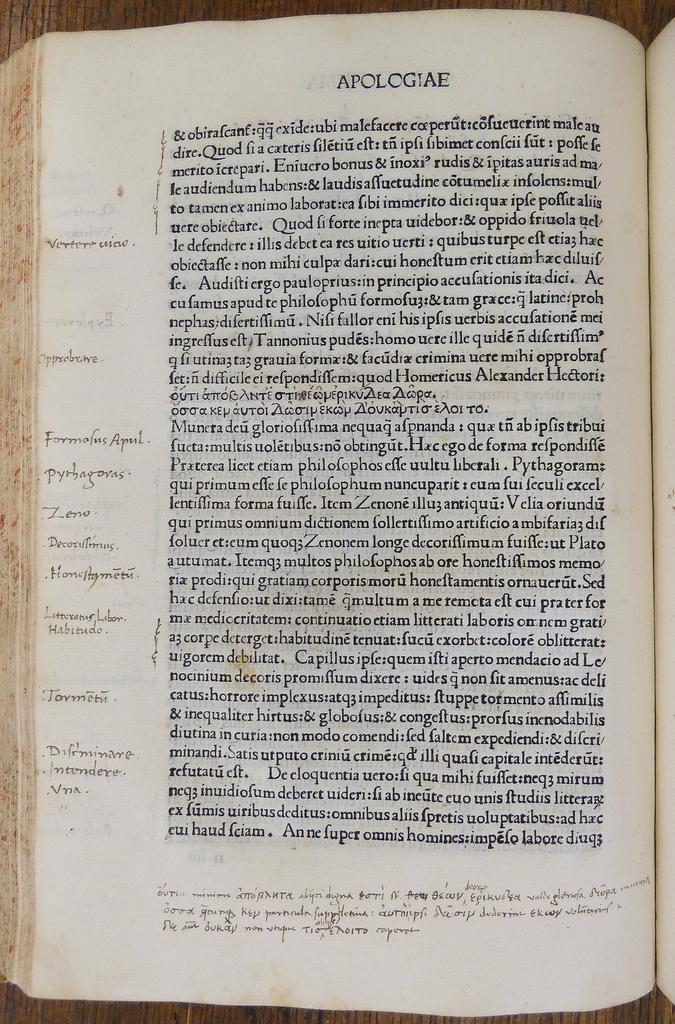What is written on top of the page?
Provide a short and direct response. Apologiae. 